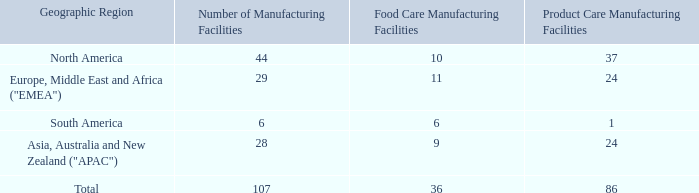We manufacture products in 107 facilities, with 15 of those facilities serving both of our business segments. The following table shows our manufacturing facilities by geographic region and our business segment reporting structure:
Other Property Information
We own the large majority of our manufacturing facilities. Some of these facilities are subject to secured or other financing arrangements. We lease the balance of our manufacturing facilities, which are generally smaller sites. Our manufacturing facilities are usually located in general purpose buildings that house our specialized machinery for the manufacture of one or more products. Because of the relatively low density of our air cellular, polyethylene foam and protective mailer products, we realize significant freight savings by locating our manufacturing facilities for these products near our customers and distributors.
We also occupy facilities containing sales, distribution, technical, warehouse or administrative functions at a number of
locations in the U.S. and in many foreign countries/regions. Some of these facilities are located on the manufacturing sites that we own and some of these are leased. Stand-alone facilities of these types are generally leased. Our global headquarters is located in an owned property in Charlotte, North Carolina. For a list of those countries and regions outside of the U.S. where we have operations, see "Global Operations" above.
We believe that our manufacturing, warehouse, office and other facilities are well maintained, suitable for their purposes and adequate for our needs.
How many facilities serve both business segments? 15. Where are the manufacturing facilities usually located? General purpose buildings. Where is the Global headquarters located? Charlotte, north carolina. How many manufacturing facilities in North America are both Food Care and Product Care? (10+37)-44
Answer: 3. What is the percentage of manufacturing facilities that are in South America?
Answer scale should be: percent. (6/107)
Answer: 5.61. How many manufacturing facilities serve only Product Care in total?  107-36
Answer: 71. 